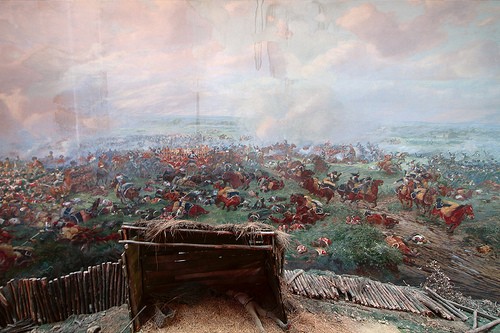<image>
Is the painting in the fence? Yes. The painting is contained within or inside the fence, showing a containment relationship. 